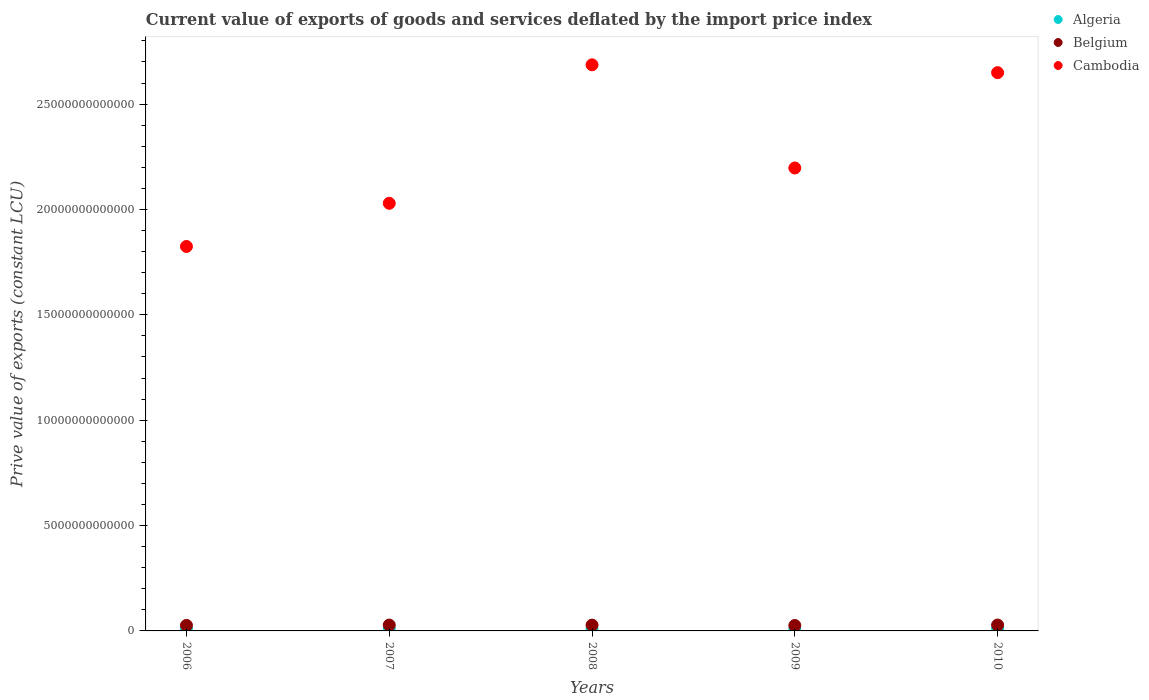Is the number of dotlines equal to the number of legend labels?
Your answer should be very brief. Yes. What is the prive value of exports in Belgium in 2009?
Ensure brevity in your answer.  2.57e+11. Across all years, what is the maximum prive value of exports in Cambodia?
Provide a succinct answer. 2.69e+13. Across all years, what is the minimum prive value of exports in Cambodia?
Ensure brevity in your answer.  1.82e+13. In which year was the prive value of exports in Cambodia maximum?
Provide a short and direct response. 2008. In which year was the prive value of exports in Algeria minimum?
Keep it short and to the point. 2009. What is the total prive value of exports in Belgium in the graph?
Your answer should be compact. 1.35e+12. What is the difference between the prive value of exports in Cambodia in 2006 and that in 2007?
Your answer should be compact. -2.05e+12. What is the difference between the prive value of exports in Algeria in 2006 and the prive value of exports in Belgium in 2010?
Your response must be concise. -1.66e+11. What is the average prive value of exports in Algeria per year?
Give a very brief answer. 9.31e+1. In the year 2009, what is the difference between the prive value of exports in Belgium and prive value of exports in Cambodia?
Your answer should be compact. -2.17e+13. In how many years, is the prive value of exports in Algeria greater than 20000000000000 LCU?
Provide a short and direct response. 0. What is the ratio of the prive value of exports in Belgium in 2006 to that in 2010?
Provide a succinct answer. 0.94. Is the prive value of exports in Cambodia in 2006 less than that in 2009?
Your answer should be very brief. Yes. Is the difference between the prive value of exports in Belgium in 2006 and 2009 greater than the difference between the prive value of exports in Cambodia in 2006 and 2009?
Provide a short and direct response. Yes. What is the difference between the highest and the second highest prive value of exports in Cambodia?
Your answer should be very brief. 3.73e+11. What is the difference between the highest and the lowest prive value of exports in Belgium?
Provide a succinct answer. 2.21e+1. In how many years, is the prive value of exports in Cambodia greater than the average prive value of exports in Cambodia taken over all years?
Your response must be concise. 2. Is the prive value of exports in Algeria strictly less than the prive value of exports in Belgium over the years?
Provide a succinct answer. Yes. How many years are there in the graph?
Your answer should be very brief. 5. What is the difference between two consecutive major ticks on the Y-axis?
Provide a short and direct response. 5.00e+12. Does the graph contain any zero values?
Your response must be concise. No. Where does the legend appear in the graph?
Give a very brief answer. Top right. What is the title of the graph?
Give a very brief answer. Current value of exports of goods and services deflated by the import price index. Does "Morocco" appear as one of the legend labels in the graph?
Your response must be concise. No. What is the label or title of the X-axis?
Offer a very short reply. Years. What is the label or title of the Y-axis?
Offer a terse response. Prive value of exports (constant LCU). What is the Prive value of exports (constant LCU) in Algeria in 2006?
Give a very brief answer. 1.13e+11. What is the Prive value of exports (constant LCU) of Belgium in 2006?
Provide a short and direct response. 2.62e+11. What is the Prive value of exports (constant LCU) in Cambodia in 2006?
Provide a succinct answer. 1.82e+13. What is the Prive value of exports (constant LCU) of Algeria in 2007?
Offer a terse response. 1.03e+11. What is the Prive value of exports (constant LCU) in Belgium in 2007?
Offer a terse response. 2.78e+11. What is the Prive value of exports (constant LCU) of Cambodia in 2007?
Give a very brief answer. 2.03e+13. What is the Prive value of exports (constant LCU) of Algeria in 2008?
Offer a terse response. 9.69e+1. What is the Prive value of exports (constant LCU) in Belgium in 2008?
Give a very brief answer. 2.75e+11. What is the Prive value of exports (constant LCU) of Cambodia in 2008?
Make the answer very short. 2.69e+13. What is the Prive value of exports (constant LCU) of Algeria in 2009?
Ensure brevity in your answer.  6.66e+1. What is the Prive value of exports (constant LCU) of Belgium in 2009?
Your answer should be compact. 2.57e+11. What is the Prive value of exports (constant LCU) of Cambodia in 2009?
Ensure brevity in your answer.  2.20e+13. What is the Prive value of exports (constant LCU) in Algeria in 2010?
Provide a succinct answer. 8.65e+1. What is the Prive value of exports (constant LCU) of Belgium in 2010?
Your response must be concise. 2.79e+11. What is the Prive value of exports (constant LCU) in Cambodia in 2010?
Ensure brevity in your answer.  2.65e+13. Across all years, what is the maximum Prive value of exports (constant LCU) in Algeria?
Keep it short and to the point. 1.13e+11. Across all years, what is the maximum Prive value of exports (constant LCU) in Belgium?
Keep it short and to the point. 2.79e+11. Across all years, what is the maximum Prive value of exports (constant LCU) of Cambodia?
Your answer should be very brief. 2.69e+13. Across all years, what is the minimum Prive value of exports (constant LCU) of Algeria?
Give a very brief answer. 6.66e+1. Across all years, what is the minimum Prive value of exports (constant LCU) of Belgium?
Your answer should be very brief. 2.57e+11. Across all years, what is the minimum Prive value of exports (constant LCU) of Cambodia?
Provide a short and direct response. 1.82e+13. What is the total Prive value of exports (constant LCU) of Algeria in the graph?
Keep it short and to the point. 4.66e+11. What is the total Prive value of exports (constant LCU) of Belgium in the graph?
Ensure brevity in your answer.  1.35e+12. What is the total Prive value of exports (constant LCU) in Cambodia in the graph?
Your answer should be compact. 1.14e+14. What is the difference between the Prive value of exports (constant LCU) of Algeria in 2006 and that in 2007?
Provide a succinct answer. 9.63e+09. What is the difference between the Prive value of exports (constant LCU) in Belgium in 2006 and that in 2007?
Provide a short and direct response. -1.54e+1. What is the difference between the Prive value of exports (constant LCU) in Cambodia in 2006 and that in 2007?
Give a very brief answer. -2.05e+12. What is the difference between the Prive value of exports (constant LCU) in Algeria in 2006 and that in 2008?
Your answer should be very brief. 1.57e+1. What is the difference between the Prive value of exports (constant LCU) in Belgium in 2006 and that in 2008?
Offer a very short reply. -1.27e+1. What is the difference between the Prive value of exports (constant LCU) in Cambodia in 2006 and that in 2008?
Give a very brief answer. -8.62e+12. What is the difference between the Prive value of exports (constant LCU) in Algeria in 2006 and that in 2009?
Your answer should be compact. 4.60e+1. What is the difference between the Prive value of exports (constant LCU) of Belgium in 2006 and that in 2009?
Offer a very short reply. 5.47e+09. What is the difference between the Prive value of exports (constant LCU) in Cambodia in 2006 and that in 2009?
Offer a very short reply. -3.72e+12. What is the difference between the Prive value of exports (constant LCU) in Algeria in 2006 and that in 2010?
Make the answer very short. 2.61e+1. What is the difference between the Prive value of exports (constant LCU) in Belgium in 2006 and that in 2010?
Your response must be concise. -1.66e+1. What is the difference between the Prive value of exports (constant LCU) in Cambodia in 2006 and that in 2010?
Your answer should be compact. -8.25e+12. What is the difference between the Prive value of exports (constant LCU) in Algeria in 2007 and that in 2008?
Keep it short and to the point. 6.06e+09. What is the difference between the Prive value of exports (constant LCU) in Belgium in 2007 and that in 2008?
Provide a short and direct response. 2.63e+09. What is the difference between the Prive value of exports (constant LCU) of Cambodia in 2007 and that in 2008?
Make the answer very short. -6.57e+12. What is the difference between the Prive value of exports (constant LCU) in Algeria in 2007 and that in 2009?
Give a very brief answer. 3.64e+1. What is the difference between the Prive value of exports (constant LCU) in Belgium in 2007 and that in 2009?
Offer a very short reply. 2.08e+1. What is the difference between the Prive value of exports (constant LCU) in Cambodia in 2007 and that in 2009?
Ensure brevity in your answer.  -1.68e+12. What is the difference between the Prive value of exports (constant LCU) in Algeria in 2007 and that in 2010?
Offer a very short reply. 1.65e+1. What is the difference between the Prive value of exports (constant LCU) of Belgium in 2007 and that in 2010?
Offer a terse response. -1.26e+09. What is the difference between the Prive value of exports (constant LCU) of Cambodia in 2007 and that in 2010?
Provide a succinct answer. -6.20e+12. What is the difference between the Prive value of exports (constant LCU) of Algeria in 2008 and that in 2009?
Provide a succinct answer. 3.03e+1. What is the difference between the Prive value of exports (constant LCU) in Belgium in 2008 and that in 2009?
Provide a succinct answer. 1.82e+1. What is the difference between the Prive value of exports (constant LCU) in Cambodia in 2008 and that in 2009?
Provide a short and direct response. 4.90e+12. What is the difference between the Prive value of exports (constant LCU) of Algeria in 2008 and that in 2010?
Keep it short and to the point. 1.04e+1. What is the difference between the Prive value of exports (constant LCU) in Belgium in 2008 and that in 2010?
Provide a succinct answer. -3.88e+09. What is the difference between the Prive value of exports (constant LCU) in Cambodia in 2008 and that in 2010?
Make the answer very short. 3.73e+11. What is the difference between the Prive value of exports (constant LCU) of Algeria in 2009 and that in 2010?
Offer a terse response. -1.99e+1. What is the difference between the Prive value of exports (constant LCU) of Belgium in 2009 and that in 2010?
Provide a short and direct response. -2.21e+1. What is the difference between the Prive value of exports (constant LCU) of Cambodia in 2009 and that in 2010?
Make the answer very short. -4.52e+12. What is the difference between the Prive value of exports (constant LCU) of Algeria in 2006 and the Prive value of exports (constant LCU) of Belgium in 2007?
Give a very brief answer. -1.65e+11. What is the difference between the Prive value of exports (constant LCU) in Algeria in 2006 and the Prive value of exports (constant LCU) in Cambodia in 2007?
Your answer should be very brief. -2.02e+13. What is the difference between the Prive value of exports (constant LCU) of Belgium in 2006 and the Prive value of exports (constant LCU) of Cambodia in 2007?
Ensure brevity in your answer.  -2.00e+13. What is the difference between the Prive value of exports (constant LCU) in Algeria in 2006 and the Prive value of exports (constant LCU) in Belgium in 2008?
Provide a succinct answer. -1.63e+11. What is the difference between the Prive value of exports (constant LCU) of Algeria in 2006 and the Prive value of exports (constant LCU) of Cambodia in 2008?
Keep it short and to the point. -2.68e+13. What is the difference between the Prive value of exports (constant LCU) of Belgium in 2006 and the Prive value of exports (constant LCU) of Cambodia in 2008?
Provide a short and direct response. -2.66e+13. What is the difference between the Prive value of exports (constant LCU) of Algeria in 2006 and the Prive value of exports (constant LCU) of Belgium in 2009?
Provide a short and direct response. -1.44e+11. What is the difference between the Prive value of exports (constant LCU) of Algeria in 2006 and the Prive value of exports (constant LCU) of Cambodia in 2009?
Give a very brief answer. -2.19e+13. What is the difference between the Prive value of exports (constant LCU) in Belgium in 2006 and the Prive value of exports (constant LCU) in Cambodia in 2009?
Make the answer very short. -2.17e+13. What is the difference between the Prive value of exports (constant LCU) of Algeria in 2006 and the Prive value of exports (constant LCU) of Belgium in 2010?
Offer a terse response. -1.66e+11. What is the difference between the Prive value of exports (constant LCU) of Algeria in 2006 and the Prive value of exports (constant LCU) of Cambodia in 2010?
Offer a very short reply. -2.64e+13. What is the difference between the Prive value of exports (constant LCU) in Belgium in 2006 and the Prive value of exports (constant LCU) in Cambodia in 2010?
Provide a short and direct response. -2.62e+13. What is the difference between the Prive value of exports (constant LCU) of Algeria in 2007 and the Prive value of exports (constant LCU) of Belgium in 2008?
Provide a short and direct response. -1.72e+11. What is the difference between the Prive value of exports (constant LCU) of Algeria in 2007 and the Prive value of exports (constant LCU) of Cambodia in 2008?
Your answer should be compact. -2.68e+13. What is the difference between the Prive value of exports (constant LCU) in Belgium in 2007 and the Prive value of exports (constant LCU) in Cambodia in 2008?
Your answer should be compact. -2.66e+13. What is the difference between the Prive value of exports (constant LCU) of Algeria in 2007 and the Prive value of exports (constant LCU) of Belgium in 2009?
Give a very brief answer. -1.54e+11. What is the difference between the Prive value of exports (constant LCU) in Algeria in 2007 and the Prive value of exports (constant LCU) in Cambodia in 2009?
Make the answer very short. -2.19e+13. What is the difference between the Prive value of exports (constant LCU) of Belgium in 2007 and the Prive value of exports (constant LCU) of Cambodia in 2009?
Your answer should be very brief. -2.17e+13. What is the difference between the Prive value of exports (constant LCU) of Algeria in 2007 and the Prive value of exports (constant LCU) of Belgium in 2010?
Keep it short and to the point. -1.76e+11. What is the difference between the Prive value of exports (constant LCU) of Algeria in 2007 and the Prive value of exports (constant LCU) of Cambodia in 2010?
Your answer should be very brief. -2.64e+13. What is the difference between the Prive value of exports (constant LCU) in Belgium in 2007 and the Prive value of exports (constant LCU) in Cambodia in 2010?
Give a very brief answer. -2.62e+13. What is the difference between the Prive value of exports (constant LCU) in Algeria in 2008 and the Prive value of exports (constant LCU) in Belgium in 2009?
Provide a short and direct response. -1.60e+11. What is the difference between the Prive value of exports (constant LCU) of Algeria in 2008 and the Prive value of exports (constant LCU) of Cambodia in 2009?
Provide a short and direct response. -2.19e+13. What is the difference between the Prive value of exports (constant LCU) in Belgium in 2008 and the Prive value of exports (constant LCU) in Cambodia in 2009?
Provide a succinct answer. -2.17e+13. What is the difference between the Prive value of exports (constant LCU) in Algeria in 2008 and the Prive value of exports (constant LCU) in Belgium in 2010?
Your response must be concise. -1.82e+11. What is the difference between the Prive value of exports (constant LCU) in Algeria in 2008 and the Prive value of exports (constant LCU) in Cambodia in 2010?
Make the answer very short. -2.64e+13. What is the difference between the Prive value of exports (constant LCU) of Belgium in 2008 and the Prive value of exports (constant LCU) of Cambodia in 2010?
Offer a terse response. -2.62e+13. What is the difference between the Prive value of exports (constant LCU) of Algeria in 2009 and the Prive value of exports (constant LCU) of Belgium in 2010?
Provide a short and direct response. -2.13e+11. What is the difference between the Prive value of exports (constant LCU) of Algeria in 2009 and the Prive value of exports (constant LCU) of Cambodia in 2010?
Your answer should be very brief. -2.64e+13. What is the difference between the Prive value of exports (constant LCU) of Belgium in 2009 and the Prive value of exports (constant LCU) of Cambodia in 2010?
Give a very brief answer. -2.62e+13. What is the average Prive value of exports (constant LCU) in Algeria per year?
Give a very brief answer. 9.31e+1. What is the average Prive value of exports (constant LCU) of Belgium per year?
Give a very brief answer. 2.70e+11. What is the average Prive value of exports (constant LCU) of Cambodia per year?
Offer a terse response. 2.28e+13. In the year 2006, what is the difference between the Prive value of exports (constant LCU) of Algeria and Prive value of exports (constant LCU) of Belgium?
Provide a succinct answer. -1.50e+11. In the year 2006, what is the difference between the Prive value of exports (constant LCU) of Algeria and Prive value of exports (constant LCU) of Cambodia?
Your answer should be compact. -1.81e+13. In the year 2006, what is the difference between the Prive value of exports (constant LCU) of Belgium and Prive value of exports (constant LCU) of Cambodia?
Your answer should be very brief. -1.80e+13. In the year 2007, what is the difference between the Prive value of exports (constant LCU) of Algeria and Prive value of exports (constant LCU) of Belgium?
Offer a very short reply. -1.75e+11. In the year 2007, what is the difference between the Prive value of exports (constant LCU) in Algeria and Prive value of exports (constant LCU) in Cambodia?
Your response must be concise. -2.02e+13. In the year 2007, what is the difference between the Prive value of exports (constant LCU) in Belgium and Prive value of exports (constant LCU) in Cambodia?
Keep it short and to the point. -2.00e+13. In the year 2008, what is the difference between the Prive value of exports (constant LCU) of Algeria and Prive value of exports (constant LCU) of Belgium?
Offer a very short reply. -1.78e+11. In the year 2008, what is the difference between the Prive value of exports (constant LCU) of Algeria and Prive value of exports (constant LCU) of Cambodia?
Your answer should be very brief. -2.68e+13. In the year 2008, what is the difference between the Prive value of exports (constant LCU) in Belgium and Prive value of exports (constant LCU) in Cambodia?
Your response must be concise. -2.66e+13. In the year 2009, what is the difference between the Prive value of exports (constant LCU) of Algeria and Prive value of exports (constant LCU) of Belgium?
Keep it short and to the point. -1.90e+11. In the year 2009, what is the difference between the Prive value of exports (constant LCU) of Algeria and Prive value of exports (constant LCU) of Cambodia?
Your answer should be compact. -2.19e+13. In the year 2009, what is the difference between the Prive value of exports (constant LCU) of Belgium and Prive value of exports (constant LCU) of Cambodia?
Your answer should be compact. -2.17e+13. In the year 2010, what is the difference between the Prive value of exports (constant LCU) of Algeria and Prive value of exports (constant LCU) of Belgium?
Your answer should be very brief. -1.93e+11. In the year 2010, what is the difference between the Prive value of exports (constant LCU) of Algeria and Prive value of exports (constant LCU) of Cambodia?
Your answer should be compact. -2.64e+13. In the year 2010, what is the difference between the Prive value of exports (constant LCU) in Belgium and Prive value of exports (constant LCU) in Cambodia?
Provide a short and direct response. -2.62e+13. What is the ratio of the Prive value of exports (constant LCU) of Algeria in 2006 to that in 2007?
Offer a very short reply. 1.09. What is the ratio of the Prive value of exports (constant LCU) in Belgium in 2006 to that in 2007?
Make the answer very short. 0.94. What is the ratio of the Prive value of exports (constant LCU) of Cambodia in 2006 to that in 2007?
Make the answer very short. 0.9. What is the ratio of the Prive value of exports (constant LCU) in Algeria in 2006 to that in 2008?
Give a very brief answer. 1.16. What is the ratio of the Prive value of exports (constant LCU) in Belgium in 2006 to that in 2008?
Offer a very short reply. 0.95. What is the ratio of the Prive value of exports (constant LCU) in Cambodia in 2006 to that in 2008?
Offer a terse response. 0.68. What is the ratio of the Prive value of exports (constant LCU) of Algeria in 2006 to that in 2009?
Make the answer very short. 1.69. What is the ratio of the Prive value of exports (constant LCU) of Belgium in 2006 to that in 2009?
Give a very brief answer. 1.02. What is the ratio of the Prive value of exports (constant LCU) of Cambodia in 2006 to that in 2009?
Your answer should be compact. 0.83. What is the ratio of the Prive value of exports (constant LCU) in Algeria in 2006 to that in 2010?
Make the answer very short. 1.3. What is the ratio of the Prive value of exports (constant LCU) of Belgium in 2006 to that in 2010?
Make the answer very short. 0.94. What is the ratio of the Prive value of exports (constant LCU) of Cambodia in 2006 to that in 2010?
Give a very brief answer. 0.69. What is the ratio of the Prive value of exports (constant LCU) in Algeria in 2007 to that in 2008?
Give a very brief answer. 1.06. What is the ratio of the Prive value of exports (constant LCU) in Belgium in 2007 to that in 2008?
Provide a succinct answer. 1.01. What is the ratio of the Prive value of exports (constant LCU) of Cambodia in 2007 to that in 2008?
Make the answer very short. 0.76. What is the ratio of the Prive value of exports (constant LCU) in Algeria in 2007 to that in 2009?
Your response must be concise. 1.55. What is the ratio of the Prive value of exports (constant LCU) of Belgium in 2007 to that in 2009?
Provide a short and direct response. 1.08. What is the ratio of the Prive value of exports (constant LCU) of Cambodia in 2007 to that in 2009?
Provide a short and direct response. 0.92. What is the ratio of the Prive value of exports (constant LCU) in Algeria in 2007 to that in 2010?
Your response must be concise. 1.19. What is the ratio of the Prive value of exports (constant LCU) in Cambodia in 2007 to that in 2010?
Provide a short and direct response. 0.77. What is the ratio of the Prive value of exports (constant LCU) in Algeria in 2008 to that in 2009?
Ensure brevity in your answer.  1.46. What is the ratio of the Prive value of exports (constant LCU) of Belgium in 2008 to that in 2009?
Your answer should be compact. 1.07. What is the ratio of the Prive value of exports (constant LCU) of Cambodia in 2008 to that in 2009?
Your response must be concise. 1.22. What is the ratio of the Prive value of exports (constant LCU) in Algeria in 2008 to that in 2010?
Give a very brief answer. 1.12. What is the ratio of the Prive value of exports (constant LCU) of Belgium in 2008 to that in 2010?
Offer a terse response. 0.99. What is the ratio of the Prive value of exports (constant LCU) of Cambodia in 2008 to that in 2010?
Your answer should be very brief. 1.01. What is the ratio of the Prive value of exports (constant LCU) in Algeria in 2009 to that in 2010?
Your answer should be very brief. 0.77. What is the ratio of the Prive value of exports (constant LCU) of Belgium in 2009 to that in 2010?
Make the answer very short. 0.92. What is the ratio of the Prive value of exports (constant LCU) in Cambodia in 2009 to that in 2010?
Offer a terse response. 0.83. What is the difference between the highest and the second highest Prive value of exports (constant LCU) of Algeria?
Your response must be concise. 9.63e+09. What is the difference between the highest and the second highest Prive value of exports (constant LCU) of Belgium?
Ensure brevity in your answer.  1.26e+09. What is the difference between the highest and the second highest Prive value of exports (constant LCU) of Cambodia?
Provide a short and direct response. 3.73e+11. What is the difference between the highest and the lowest Prive value of exports (constant LCU) in Algeria?
Make the answer very short. 4.60e+1. What is the difference between the highest and the lowest Prive value of exports (constant LCU) of Belgium?
Your answer should be very brief. 2.21e+1. What is the difference between the highest and the lowest Prive value of exports (constant LCU) in Cambodia?
Your answer should be compact. 8.62e+12. 